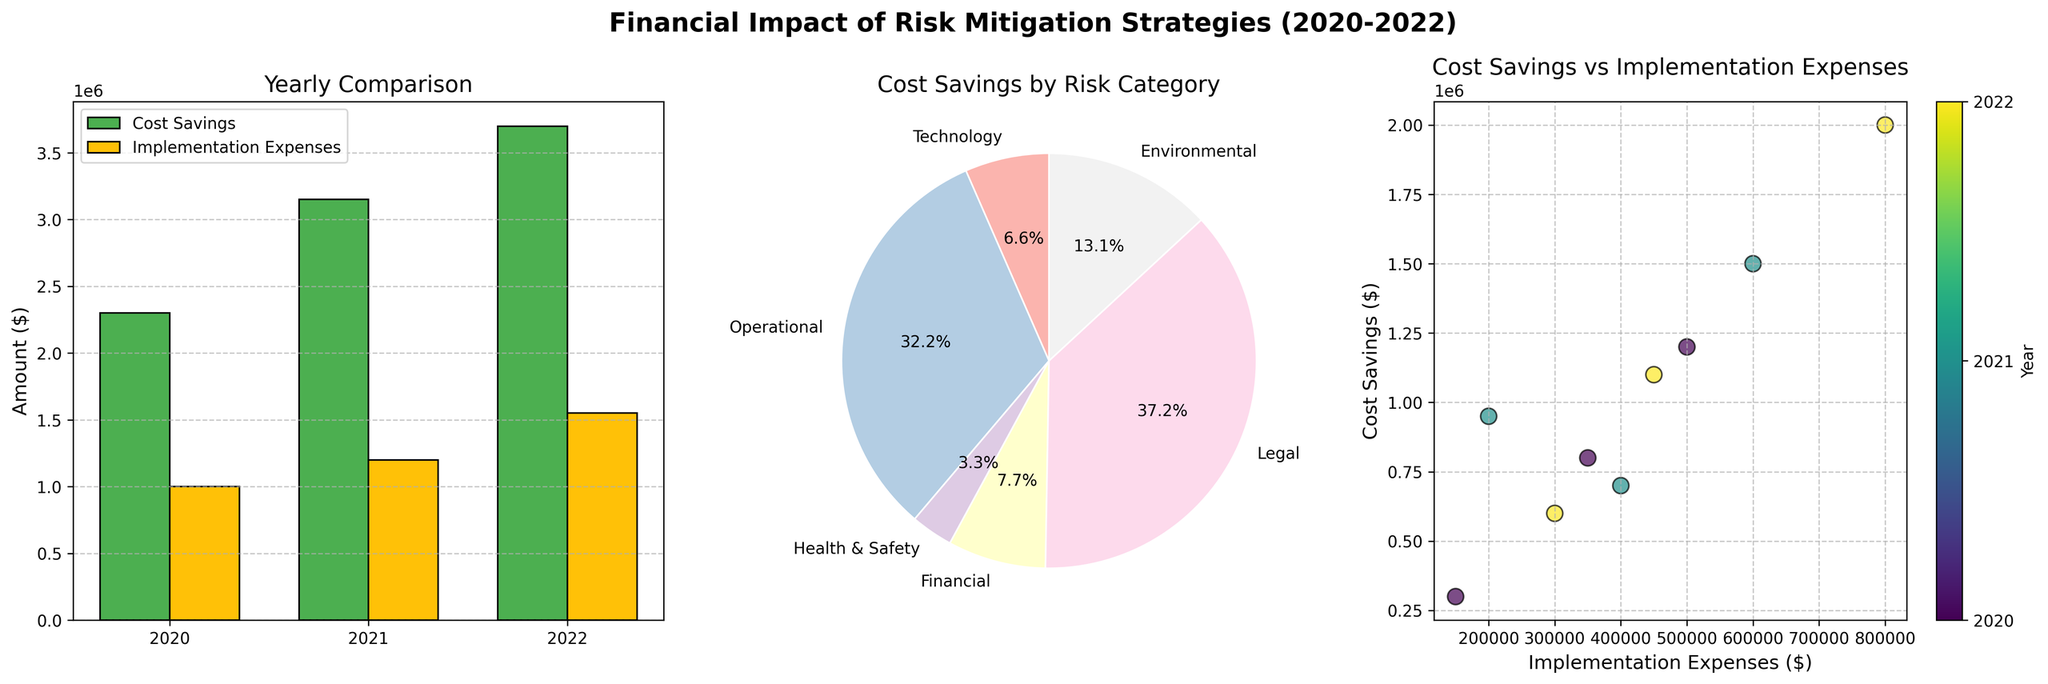What's the total cost savings in 2021? To find the total cost savings in 2021, refer to the bar chart. The bar for 2021 labeled "Cost Savings" shows a value of 3,150,000.
Answer: 3,150,000 What's the risk category with the highest cost savings? Refer to the pie chart for cost savings by risk category. Cybersecurity Enhancement has the highest slice, corresponding to the highest cost savings.
Answer: Technology How do the implementation expenses in 2022 compare to those in 2020? Look at the bar chart. The bar heights for "Implementation Expenses" in 2022 and 2020 show that the amount is higher in 2022 ($1,550,000 vs. $1,000,000).
Answer: Higher in 2022 Which year had the highest total implementation expenses? Refer to the bar chart's "Implementation Expenses" for each year. The highest bar represents 2022 with $1,550,000.
Answer: 2022 Is there a significant difference between the cost savings and implementation expenses for 2020? In 2020, the bar chart shows cost savings of $2,300,000 and implementation expenses of $1,000,000. The difference is $1,300,000, which is significant.
Answer: Yes What is the relationship between implementation expenses and cost savings in terms of trends over the years? Look at the bar chart to observe trends. Both implementation expenses and cost savings increase yearly, but cost savings increase more substantially.
Answer: Both increase, but cost savings increase more Which year had the largest difference between cost savings and implementation expenses? Calculate the difference for each year based on the bar chart: 
- 2020: 2,300,000 - 1,000,000 = 1,300,000
- 2021: 3,150,000 - 1,200,000 = 1,950,000
- 2022: 3,700,000 - 1,550,000 = 2,150,000
2022 has the largest difference.
Answer: 2022 How is the implementation expense of the Fraud Detection System in 2022 related to the cost savings of the same strategy? Refer to the scatter plot for this relationship. For the Fraud Detection System in 2022, the coordinates show implementation expenses of $800,000 and cost savings of $2,000,000.
Answer: Implementation expenses are lower than cost savings What pattern can be observed in the scatter plot? The scatter plot shows data points representing each strategy's implementation expenses versus cost savings. There is a trend where higher implementation expenses generally lead to higher cost savings.
Answer: Higher expenses lead to higher savings 